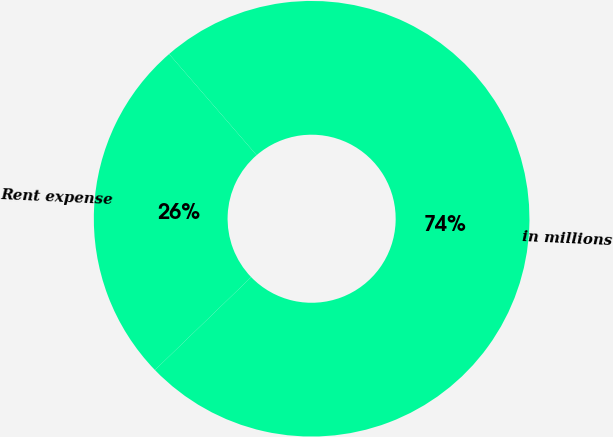<chart> <loc_0><loc_0><loc_500><loc_500><pie_chart><fcel>in millions<fcel>Rent expense<nl><fcel>74.13%<fcel>25.87%<nl></chart> 